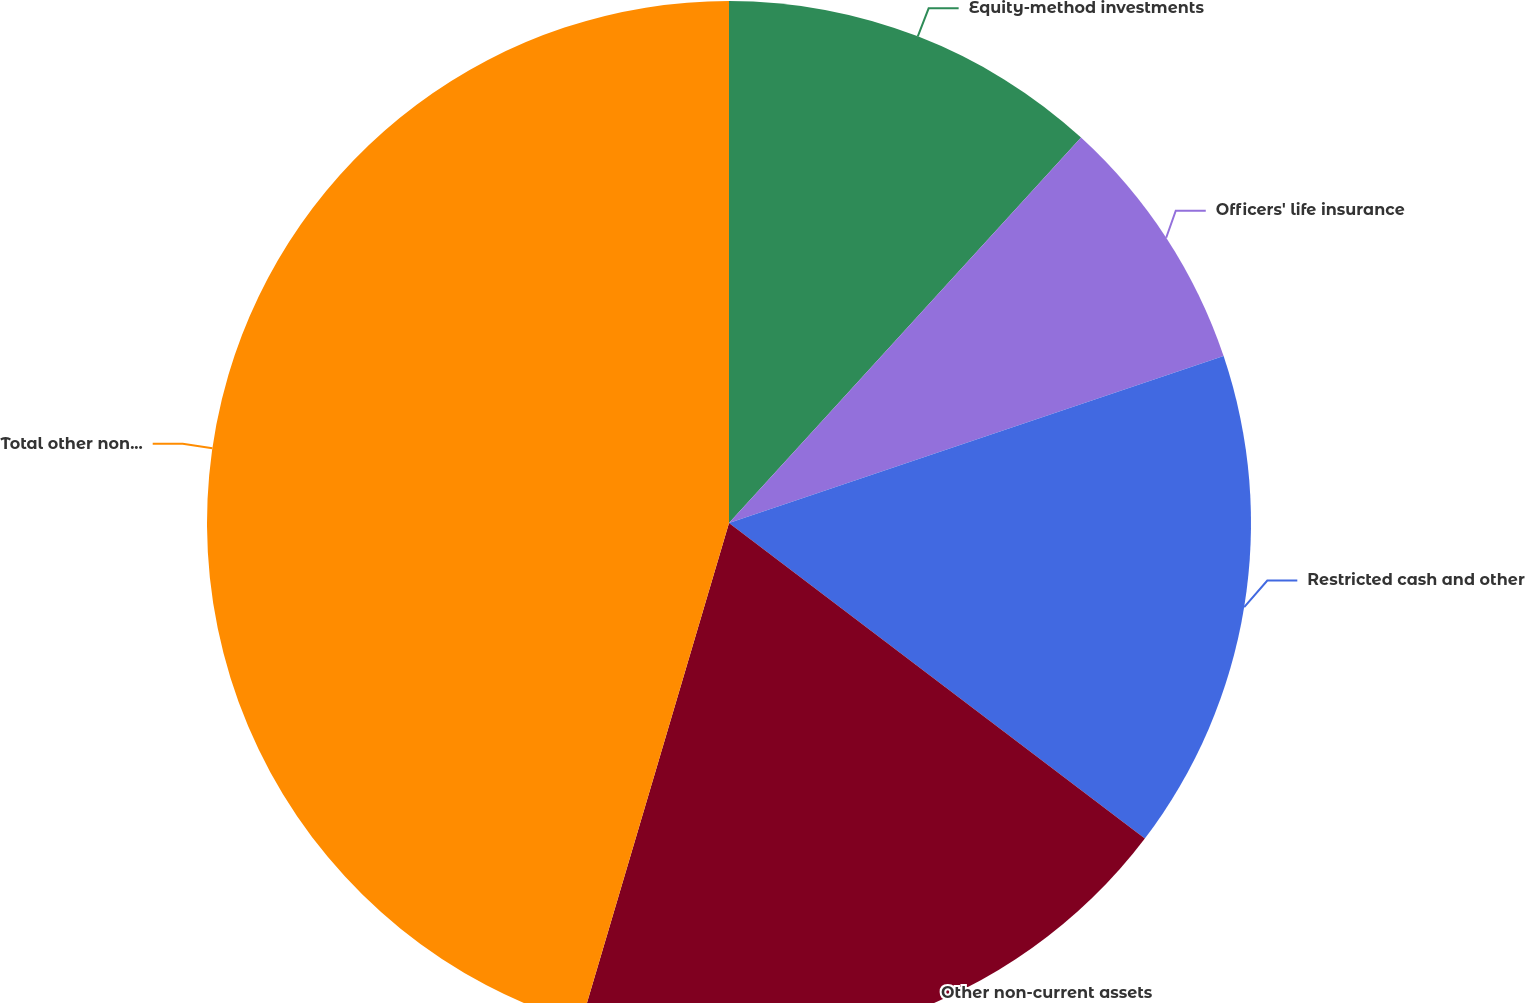Convert chart to OTSL. <chart><loc_0><loc_0><loc_500><loc_500><pie_chart><fcel>Equity-method investments<fcel>Officers' life insurance<fcel>Restricted cash and other<fcel>Other non-current assets<fcel>Total other non-current assets<nl><fcel>11.78%<fcel>8.04%<fcel>15.51%<fcel>19.25%<fcel>45.42%<nl></chart> 